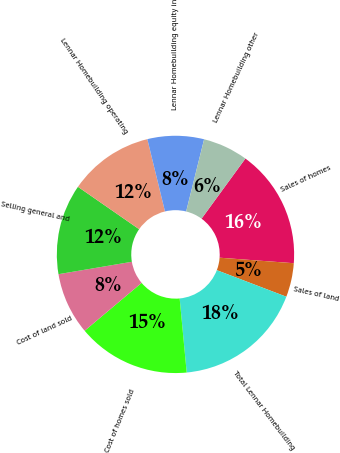Convert chart. <chart><loc_0><loc_0><loc_500><loc_500><pie_chart><fcel>Sales of homes<fcel>Sales of land<fcel>Total Lennar Homebuilding<fcel>Cost of homes sold<fcel>Cost of land sold<fcel>Selling general and<fcel>Lennar Homebuilding operating<fcel>Lennar Homebuilding equity in<fcel>Lennar Homebuilding other<nl><fcel>16.15%<fcel>4.62%<fcel>17.69%<fcel>15.38%<fcel>8.46%<fcel>12.31%<fcel>11.54%<fcel>7.69%<fcel>6.15%<nl></chart> 